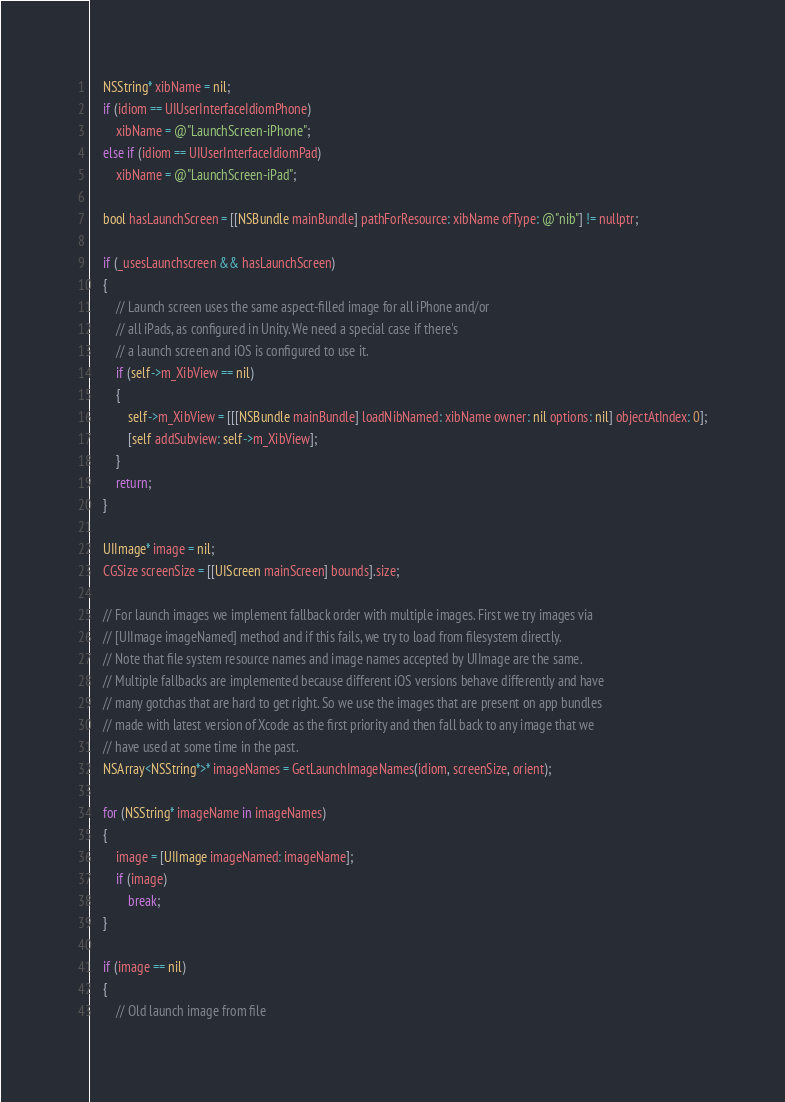Convert code to text. <code><loc_0><loc_0><loc_500><loc_500><_ObjectiveC_>
    NSString* xibName = nil;
    if (idiom == UIUserInterfaceIdiomPhone)
        xibName = @"LaunchScreen-iPhone";
    else if (idiom == UIUserInterfaceIdiomPad)
        xibName = @"LaunchScreen-iPad";

    bool hasLaunchScreen = [[NSBundle mainBundle] pathForResource: xibName ofType: @"nib"] != nullptr;

    if (_usesLaunchscreen && hasLaunchScreen)
    {
        // Launch screen uses the same aspect-filled image for all iPhone and/or
        // all iPads, as configured in Unity. We need a special case if there's
        // a launch screen and iOS is configured to use it.
        if (self->m_XibView == nil)
        {
            self->m_XibView = [[[NSBundle mainBundle] loadNibNamed: xibName owner: nil options: nil] objectAtIndex: 0];
            [self addSubview: self->m_XibView];
        }
        return;
    }

    UIImage* image = nil;
    CGSize screenSize = [[UIScreen mainScreen] bounds].size;

    // For launch images we implement fallback order with multiple images. First we try images via
    // [UIImage imageNamed] method and if this fails, we try to load from filesystem directly.
    // Note that file system resource names and image names accepted by UIImage are the same.
    // Multiple fallbacks are implemented because different iOS versions behave differently and have
    // many gotchas that are hard to get right. So we use the images that are present on app bundles
    // made with latest version of Xcode as the first priority and then fall back to any image that we
    // have used at some time in the past.
    NSArray<NSString*>* imageNames = GetLaunchImageNames(idiom, screenSize, orient);

    for (NSString* imageName in imageNames)
    {
        image = [UIImage imageNamed: imageName];
        if (image)
            break;
    }

    if (image == nil)
    {
        // Old launch image from file</code> 